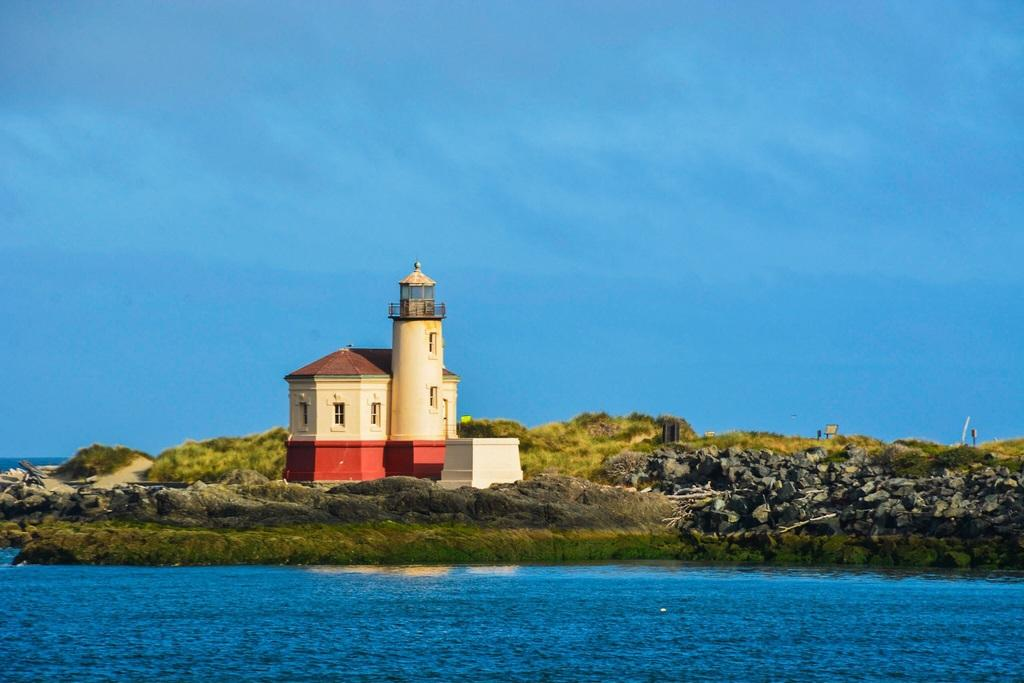What type of structure is visible in the image? There is a house in the image. Where is the house located in relation to other features? The house is visible in front of a lake. What can be seen on the right side of the image? There are stones on the right side of the image. What is visible at the top of the image? The sky is visible at the top of the image. What type of holiday is being celebrated in the image? There is no indication of a holiday being celebrated in the image. What game is being played in the image? There is no game being played in the image. 